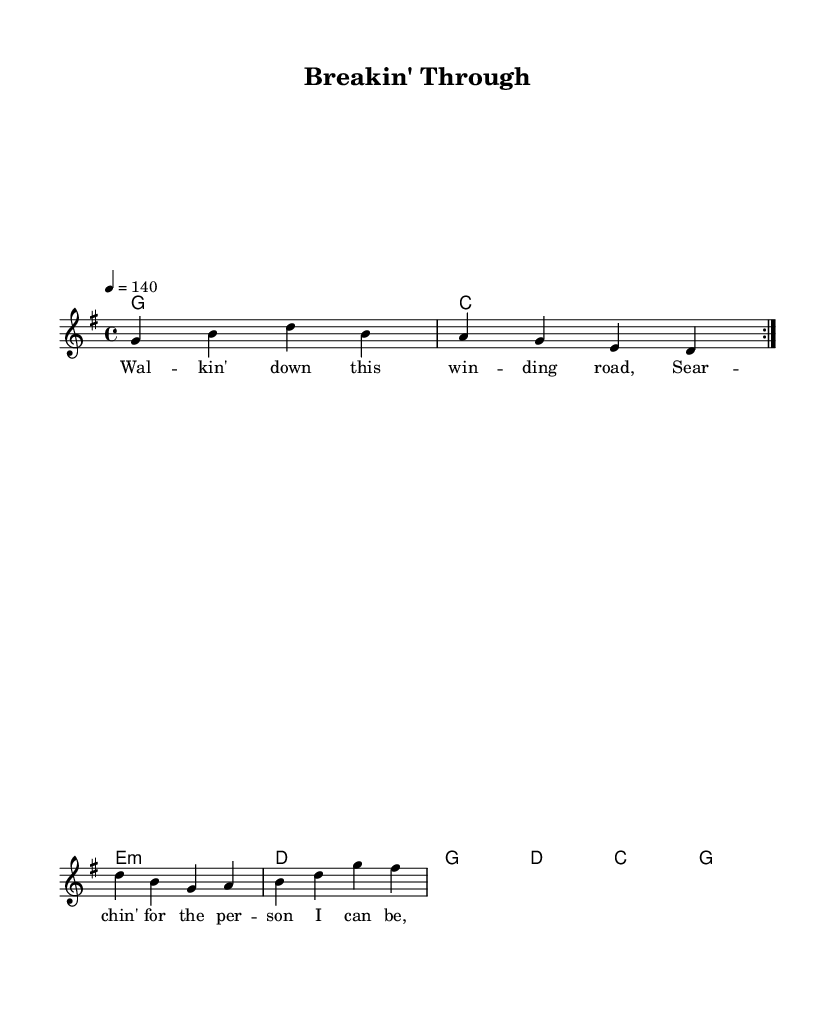What is the key signature of this music? The key signature is G major, which has one sharp (F#). This can be identified at the beginning of the music sheet where the key is indicated.
Answer: G major What is the time signature of this music? The time signature is 4/4, which is displayed at the beginning of the score and indicates that there are four beats per measure.
Answer: 4/4 What is the tempo marking for this piece? The tempo marking is 140 beats per minute, denoted at the beginning of the score with "4 = 140", indicating how fast the music should be played.
Answer: 140 How many measures are there in the verse? There are four measures in the verse, which can be counted from the melody section under the verse lyrics in the sheet music.
Answer: 4 In which section does the lyrics describe self-discovery? The self-discovery theme appears in the chorus, where the lyrics "I'm breakin' through the walls I've built" reflect a personal transformation narrative. This thematic focus can be identified in the lyrics area associated with the chorus.
Answer: chorus What type of chords accompany the verses? The chords accompanying the verses are G, C, E minor, and D, as indicated in the chord section with their respective notations above the melody in the score.
Answer: G, C, E minor, D What lyric device is used in the chorus? The chorus employs repetition, as seen with the phrase "let me go," which emphasizes the struggle for release and transformation. This can be interpreted from the repeated motifs in the lyrics provided.
Answer: repetition 